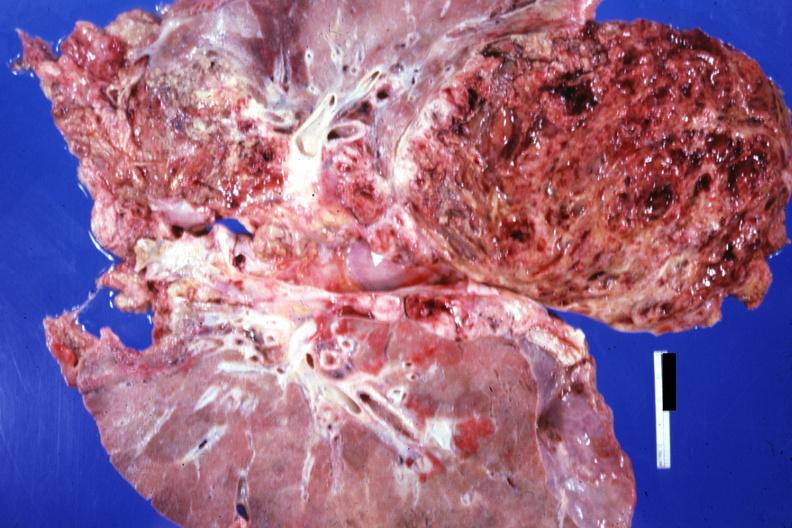does gross photo of tumor in this file show frontal section of lungs and massive tumor teratocarcinoma 20yowm?
Answer the question using a single word or phrase. No 